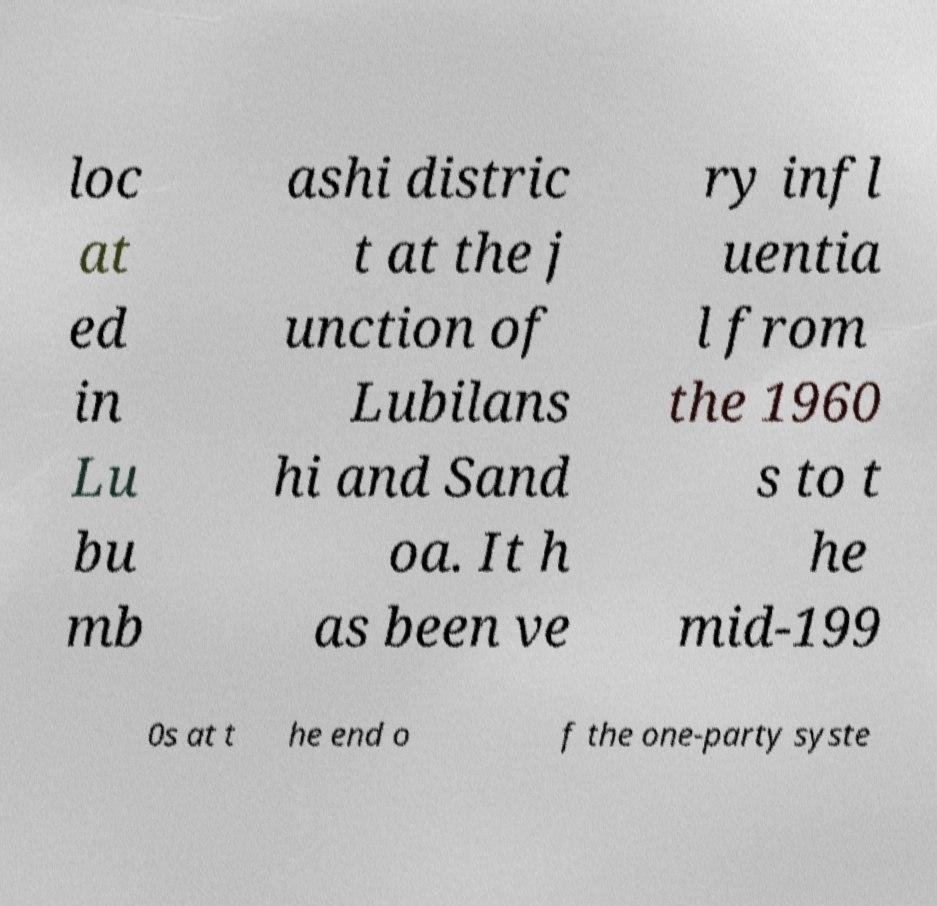What messages or text are displayed in this image? I need them in a readable, typed format. loc at ed in Lu bu mb ashi distric t at the j unction of Lubilans hi and Sand oa. It h as been ve ry infl uentia l from the 1960 s to t he mid-199 0s at t he end o f the one-party syste 